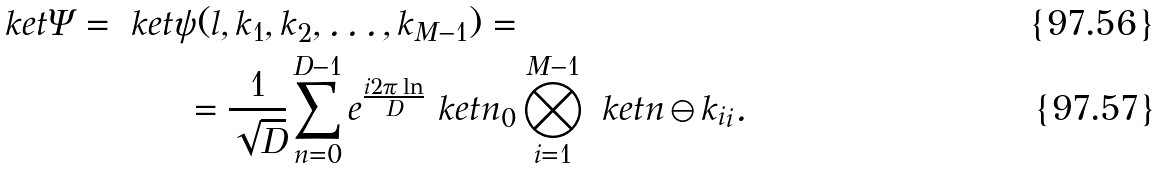Convert formula to latex. <formula><loc_0><loc_0><loc_500><loc_500>\ k e t { \Psi } = \ k e t { \psi ( l , k _ { 1 } , k _ { 2 } , \dots , k _ { M - 1 } ) } = & \\ = \frac { 1 } { \sqrt { D } } \sum _ { n = 0 } ^ { D - 1 } e ^ { \frac { i 2 \pi \ln } { D } } \ k e t { n } _ { 0 } & \bigotimes _ { i = 1 } ^ { M - 1 } \ k e t { n \ominus k _ { i } } _ { i } .</formula> 